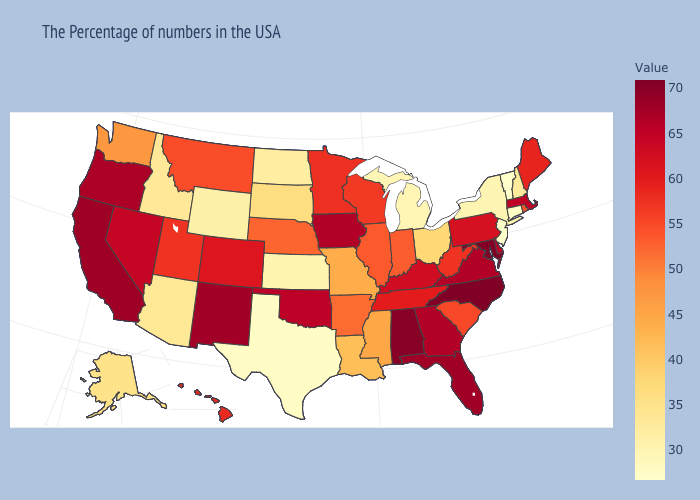Does California have the highest value in the West?
Keep it brief. Yes. Does Kentucky have a lower value than Wisconsin?
Quick response, please. No. Which states have the highest value in the USA?
Short answer required. North Carolina. Which states have the highest value in the USA?
Keep it brief. North Carolina. Among the states that border Ohio , which have the lowest value?
Be succinct. Michigan. Which states have the highest value in the USA?
Write a very short answer. North Carolina. Is the legend a continuous bar?
Quick response, please. Yes. Is the legend a continuous bar?
Short answer required. Yes. 